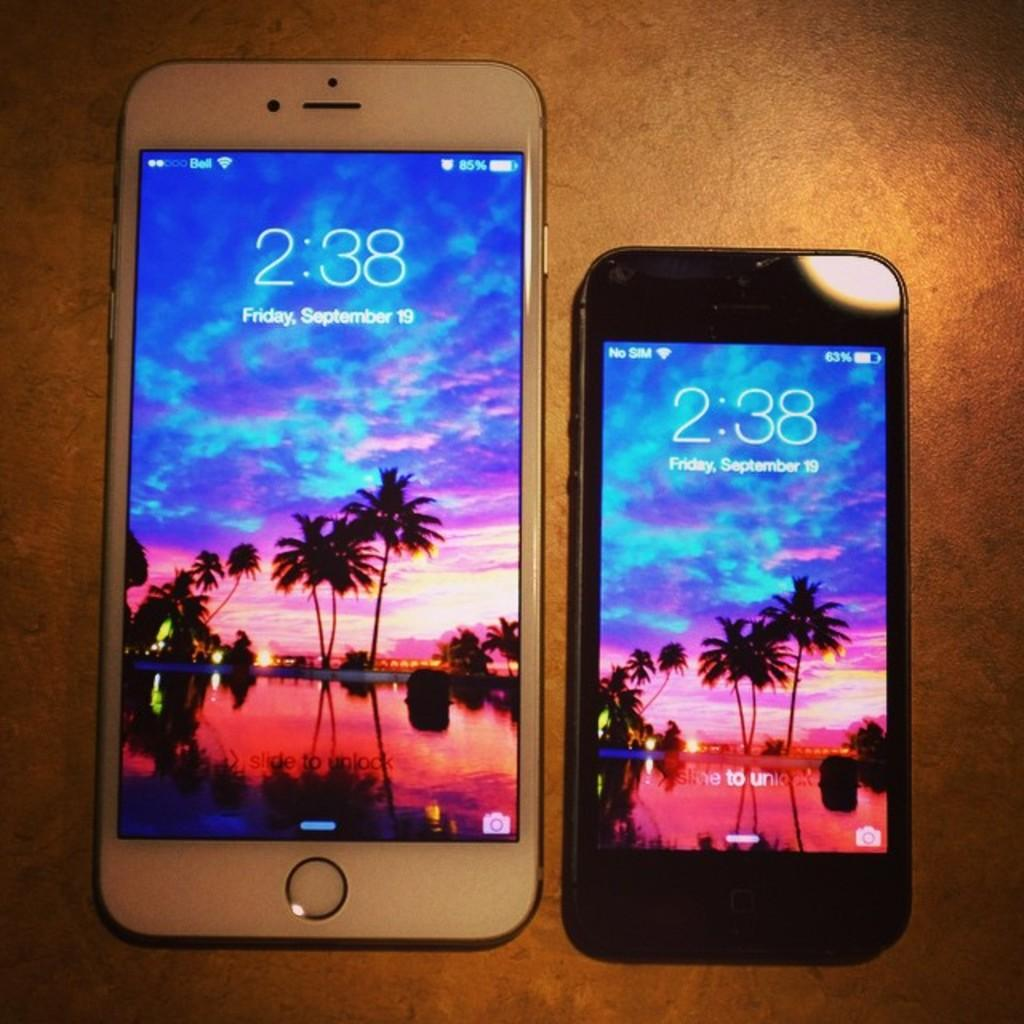Provide a one-sentence caption for the provided image. Two cell phones both display the date of Friday, September 19th. 